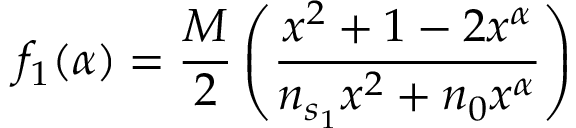Convert formula to latex. <formula><loc_0><loc_0><loc_500><loc_500>f _ { 1 } ( \alpha ) = \frac { M } { 2 } \left ( \frac { x ^ { 2 } + 1 - 2 x ^ { \alpha } } { n _ { s _ { 1 } } x ^ { 2 } + n _ { 0 } x ^ { \alpha } } \right )</formula> 